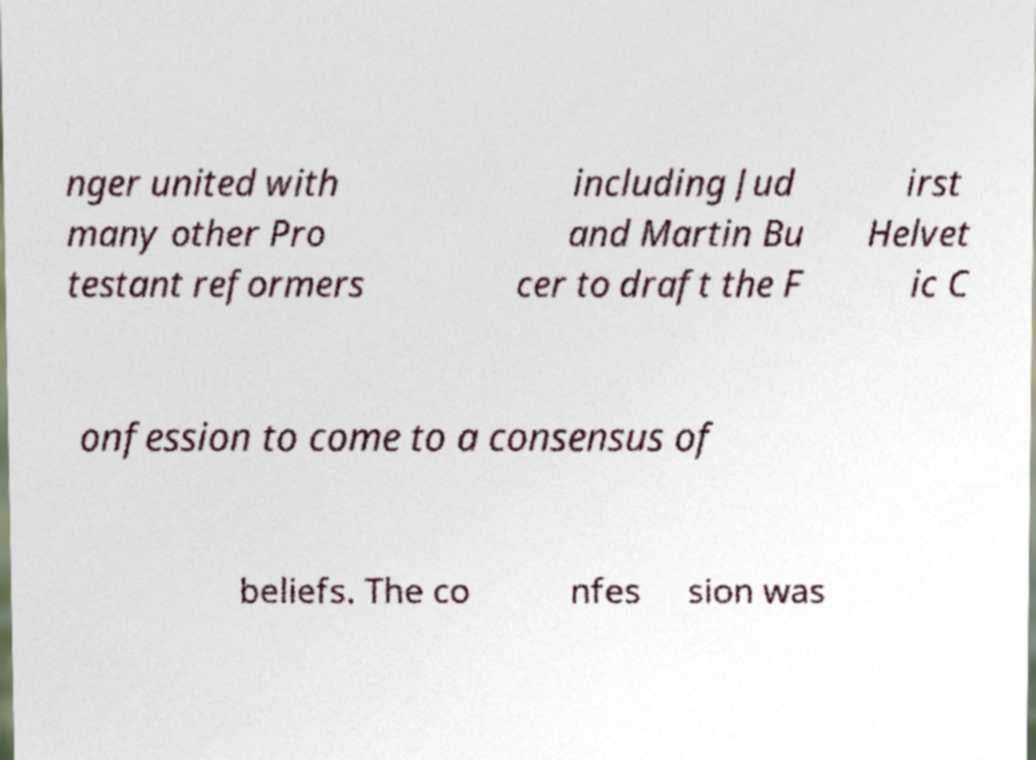What messages or text are displayed in this image? I need them in a readable, typed format. nger united with many other Pro testant reformers including Jud and Martin Bu cer to draft the F irst Helvet ic C onfession to come to a consensus of beliefs. The co nfes sion was 